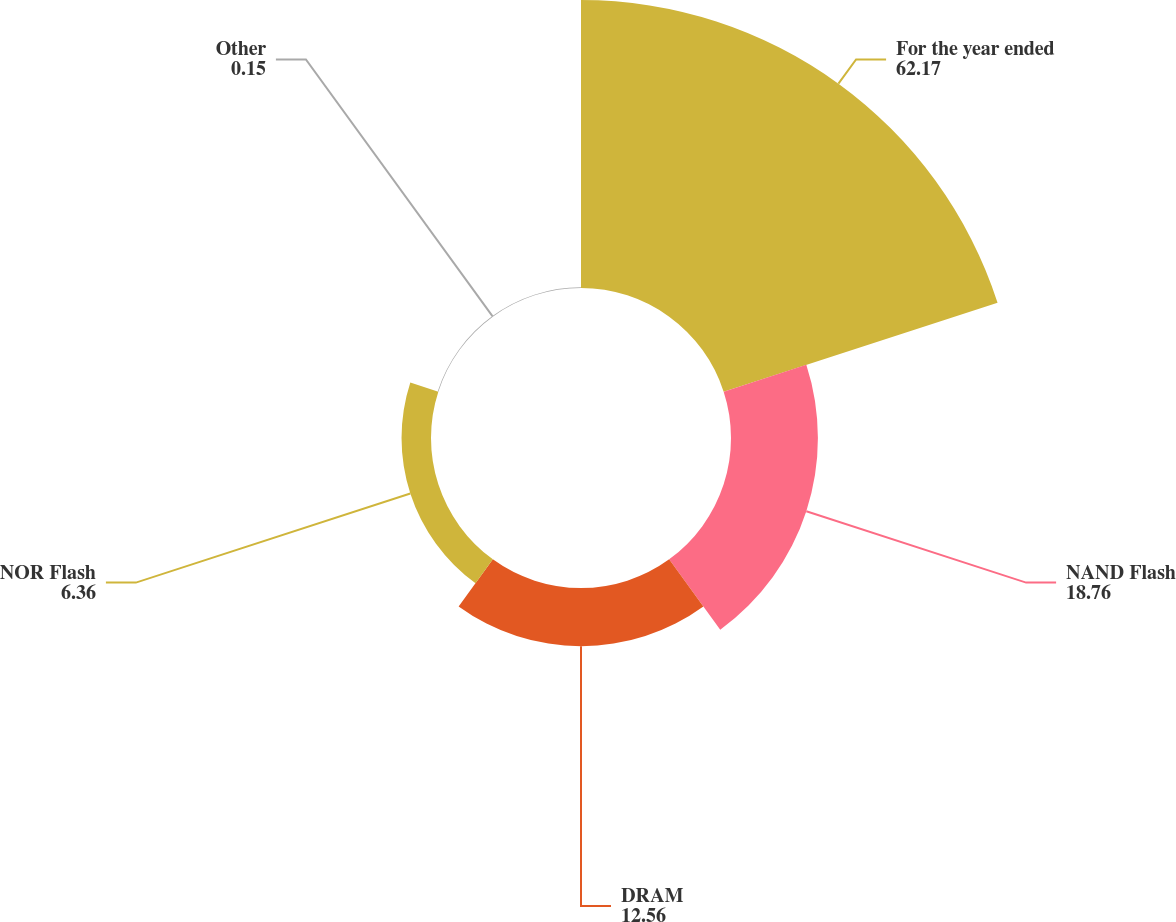<chart> <loc_0><loc_0><loc_500><loc_500><pie_chart><fcel>For the year ended<fcel>NAND Flash<fcel>DRAM<fcel>NOR Flash<fcel>Other<nl><fcel>62.17%<fcel>18.76%<fcel>12.56%<fcel>6.36%<fcel>0.15%<nl></chart> 